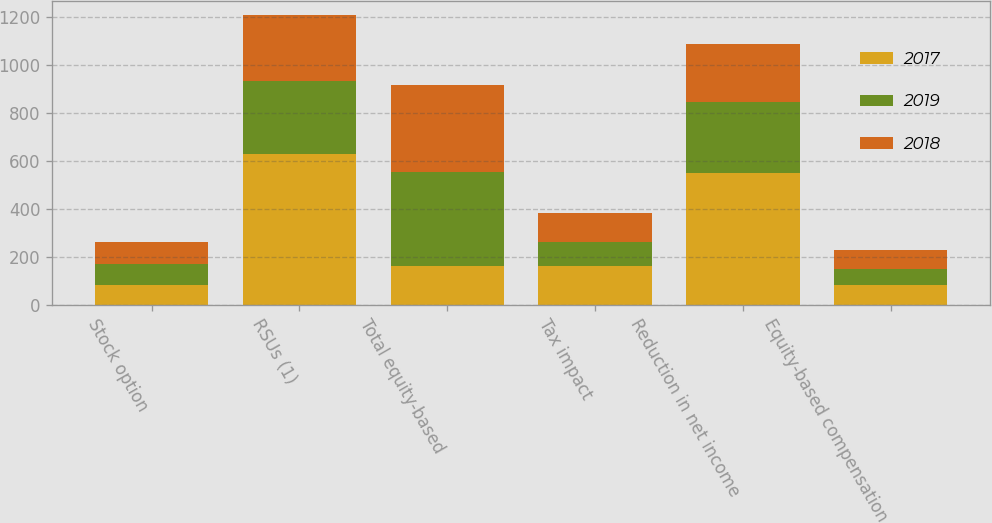Convert chart to OTSL. <chart><loc_0><loc_0><loc_500><loc_500><stacked_bar_chart><ecel><fcel>Stock option<fcel>RSUs (1)<fcel>Total equity-based<fcel>Tax impact<fcel>Reduction in net income<fcel>Equity-based compensation<nl><fcel>2017<fcel>84<fcel>627<fcel>161<fcel>161<fcel>550<fcel>81<nl><fcel>2019<fcel>87<fcel>306<fcel>393<fcel>99<fcel>294<fcel>70<nl><fcel>2018<fcel>90<fcel>274<fcel>364<fcel>123<fcel>241<fcel>78<nl></chart> 